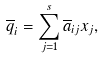Convert formula to latex. <formula><loc_0><loc_0><loc_500><loc_500>\overline { q } _ { i } = \sum _ { j = 1 } ^ { s } \overline { a } _ { i j } x _ { j } ,</formula> 